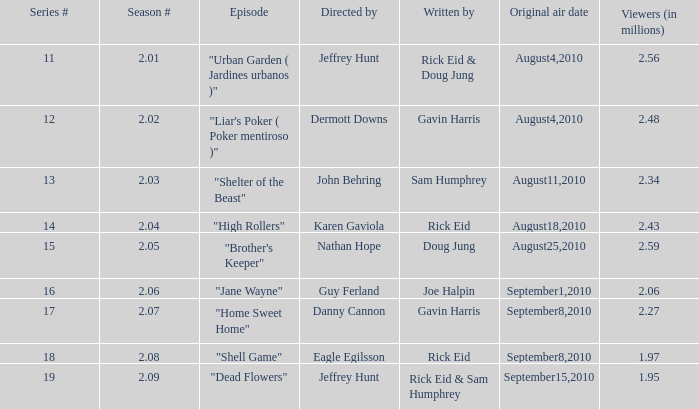Can you identify the author of the episode from season 2.08? Rick Eid. 